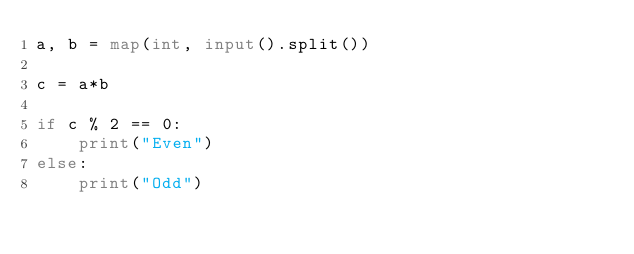Convert code to text. <code><loc_0><loc_0><loc_500><loc_500><_Python_>a, b = map(int, input().split())

c = a*b

if c % 2 == 0:
    print("Even")
else:
    print("Odd")

</code> 